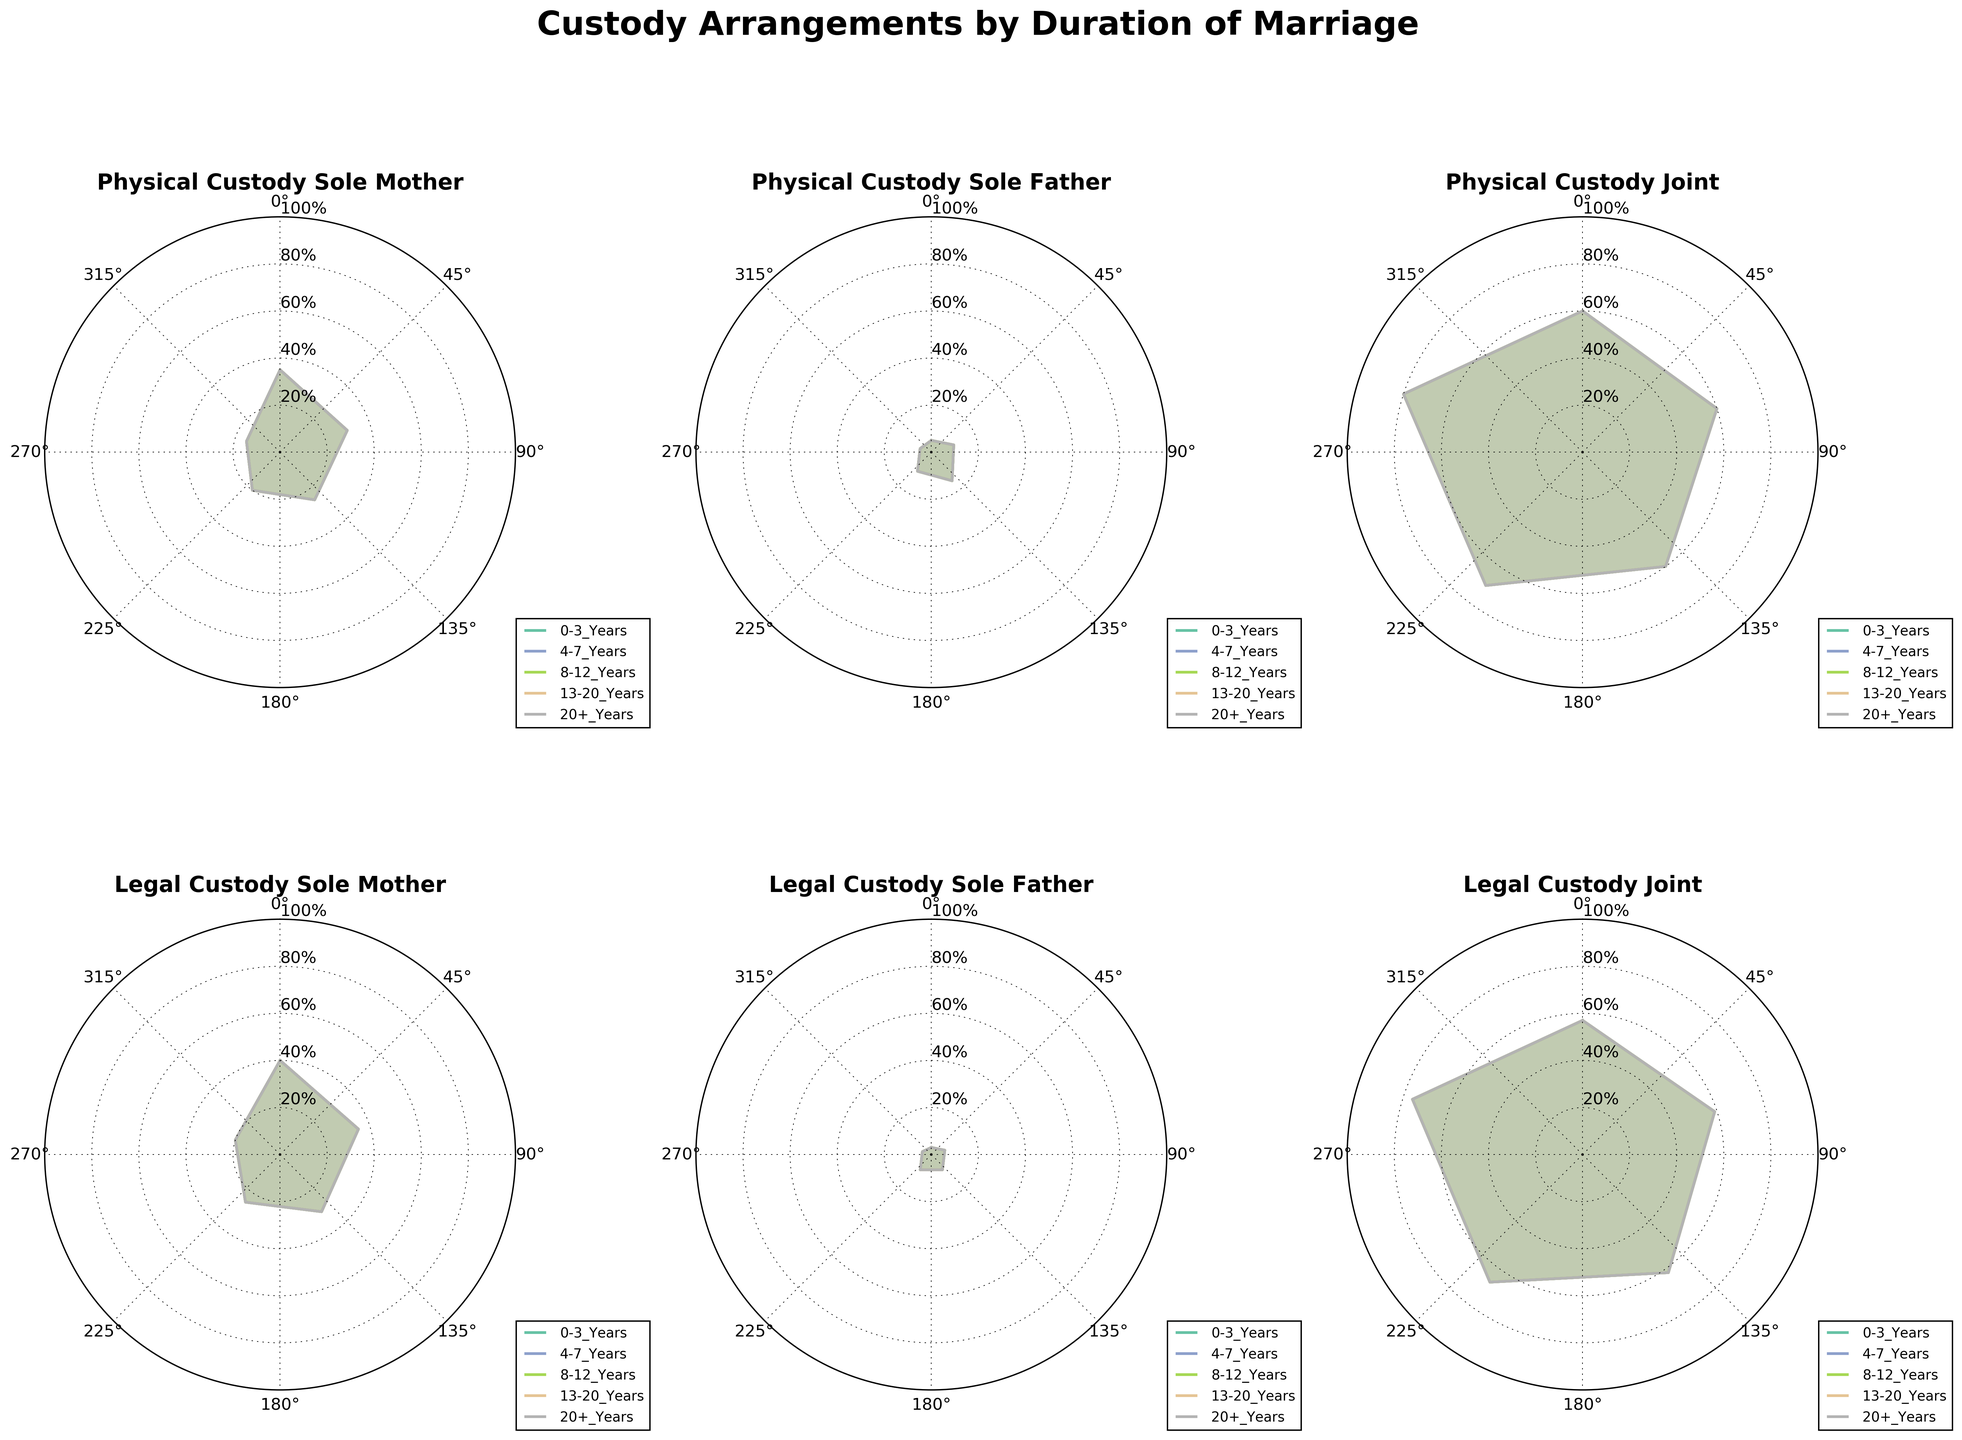What is the title of the figure? The title of the figure is located at the top of the chart and often summarizes what the chart is about. In this case, it should be clearly visible at the top.
Answer: Custody Arrangements by Duration of Marriage How many types of custody arrangements are displayed in the figure? By looking at the individual titles of the subplots in the figure, we can count the distinct types of custody arrangements.
Answer: Six Which duration of marriage has the highest percentage of Physical Custody Joint? To answer this, we need to look at the subplot titled "Physical Custody Joint" and see which duration of marriage has the highest value on the radial axis.
Answer: 20+ Years Does Legal Custody Sole Mother decrease or increase as the duration of marriage increases? By looking at the subplot titled "Legal Custody Sole Mother," we need to observe if the values decrease or increase with longer durations of marriage.
Answer: Decrease What is the percentage of Legal Custody Joint for marriages lasting 0-3 Years? To find this, we need to look at the subplot titled "Legal Custody Joint" and find the corresponding value for the 0-3 Years category.
Answer: 57% How does the percentage of Physical Custody Sole Father vary between 0-3 Years and 8-12 Years? We compare the percentage values for the 0-3 Years and 8-12 Years categories in the subplot titled "Physical Custody Sole Father."
Answer: Increase from 5% to 15% Which type of custody arrangement consistently shows a higher percentage for longer marriage durations? We need to compare the trends across all six subplots and identify which custody arrangement shows an increasing pattern.
Answer: Physical Custody Joint What is the average percentage of Legal Custody Sole Father across all durations of marriage? To find this, we sum up the percentages for Legal Custody Sole Father across all durations and divide by the number of categories (5). (3 + 6 + 8 + 8 + 4) / 5 = 5.8
Answer: 5.8% Between Physical Custody Sole Mother and Legal Custody Sole Mother, which has a higher percentage for marriages lasting 13-20 Years? Compare the values of "Physical Custody Sole Mother" with "Legal Custody Sole Mother" for the 13-20 Years category.
Answer: Legal Custody Sole Mother Which type of custody arrangement has the lowest overall percentage across all durations of marriage? By looking across all subplots, we identify the custody arrangement with the consistently lowest values.
Answer: Physical Custody Sole Father 